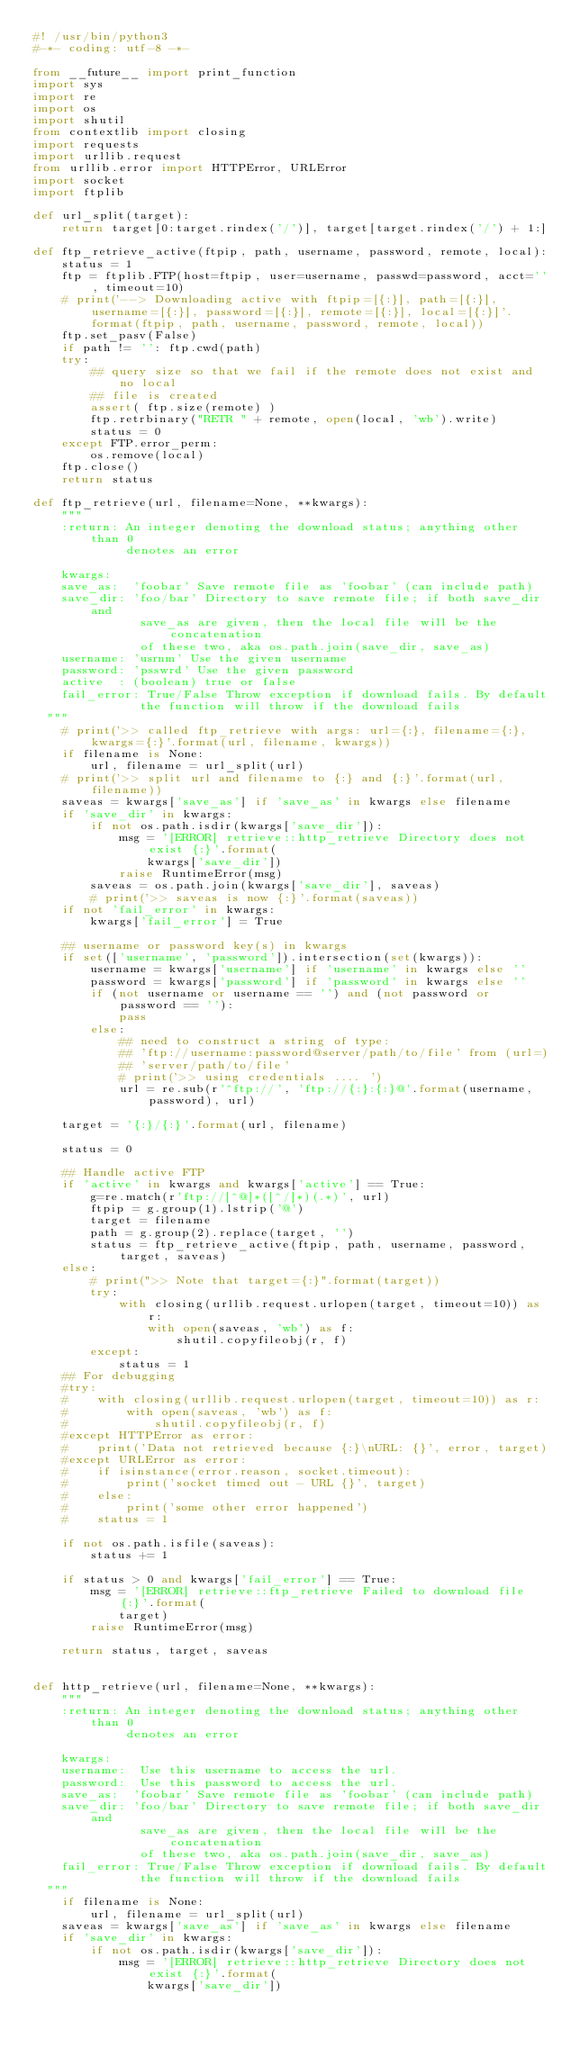<code> <loc_0><loc_0><loc_500><loc_500><_Python_>#! /usr/bin/python3
#-*- coding: utf-8 -*-

from __future__ import print_function
import sys
import re
import os
import shutil
from contextlib import closing
import requests
import urllib.request
from urllib.error import HTTPError, URLError
import socket
import ftplib

def url_split(target):
    return target[0:target.rindex('/')], target[target.rindex('/') + 1:]

def ftp_retrieve_active(ftpip, path, username, password, remote, local):
    status = 1
    ftp = ftplib.FTP(host=ftpip, user=username, passwd=password, acct='', timeout=10)
    # print('--> Downloading active with ftpip=[{:}], path=[{:}], username=[{:}], password=[{:}], remote=[{:}], local=[{:}]'.format(ftpip, path, username, password, remote, local))
    ftp.set_pasv(False)
    if path != '': ftp.cwd(path)
    try:
        ## query size so that we fail if the remote does not exist and no local
        ## file is created
        assert( ftp.size(remote) )
        ftp.retrbinary("RETR " + remote, open(local, 'wb').write)
        status = 0
    except FTP.error_perm:
        os.remove(local)
    ftp.close()
    return status

def ftp_retrieve(url, filename=None, **kwargs):
    """
    :return: An integer denoting the download status; anything other than 0 
             denotes an error

    kwargs:
    save_as:  'foobar' Save remote file as 'foobar' (can include path)
    save_dir: 'foo/bar' Directory to save remote file; if both save_dir and 
               save_as are given, then the local file will be the concatenation
               of these two, aka os.path.join(save_dir, save_as)
    username: 'usrnm' Use the given username
    password: 'psswrd' Use the given password
    active  : (boolean) true or false
    fail_error: True/False Throw exception if download fails. By default
               the function will throw if the download fails
  """
    # print('>> called ftp_retrieve with args: url={:}, filename={:}, kwargs={:}'.format(url, filename, kwargs))
    if filename is None:
        url, filename = url_split(url)
    # print('>> split url and filename to {:} and {:}'.format(url, filename))
    saveas = kwargs['save_as'] if 'save_as' in kwargs else filename
    if 'save_dir' in kwargs:
        if not os.path.isdir(kwargs['save_dir']):
            msg = '[ERROR] retrieve::http_retrieve Directory does not exist {:}'.format(
                kwargs['save_dir'])
            raise RuntimeError(msg)
        saveas = os.path.join(kwargs['save_dir'], saveas)
        # print('>> saveas is now {:}'.format(saveas))
    if not 'fail_error' in kwargs:
        kwargs['fail_error'] = True

    ## username or password key(s) in kwargs
    if set(['username', 'password']).intersection(set(kwargs)):
        username = kwargs['username'] if 'username' in kwargs else ''
        password = kwargs['password'] if 'password' in kwargs else ''
        if (not username or username == '') and (not password or password == ''):
            pass
        else:
            ## need to construct a string of type:
            ## 'ftp://username:password@server/path/to/file' from (url=)
            ## 'server/path/to/file'
            # print('>> using credentials .... ')
            url = re.sub(r'^ftp://', 'ftp://{:}:{:}@'.format(username, password), url)

    target = '{:}/{:}'.format(url, filename)

    status = 0
    
    ## Handle active FTP
    if 'active' in kwargs and kwargs['active'] == True:
        g=re.match(r'ftp://[^@]*([^/]*)(.*)', url)
        ftpip = g.group(1).lstrip('@')
        target = filename
        path = g.group(2).replace(target, '')
        status = ftp_retrieve_active(ftpip, path, username, password, target, saveas)
    else:
        # print(">> Note that target={:}".format(target))
        try:
            with closing(urllib.request.urlopen(target, timeout=10)) as r:
                with open(saveas, 'wb') as f:
                    shutil.copyfileobj(r, f)
        except:
            status = 1
    ## For debugging
    #try:
    #    with closing(urllib.request.urlopen(target, timeout=10)) as r:
    #        with open(saveas, 'wb') as f:
    #            shutil.copyfileobj(r, f)
    #except HTTPError as error:
    #    print('Data not retrieved because {:}\nURL: {}', error, target)
    #except URLError as error:
    #    if isinstance(error.reason, socket.timeout):
    #        print('socket timed out - URL {}', target)
    #    else:
    #        print('some other error happened')
    #    status = 1
    
    if not os.path.isfile(saveas):
        status += 1

    if status > 0 and kwargs['fail_error'] == True:
        msg = '[ERROR] retrieve::ftp_retrieve Failed to download file {:}'.format(
            target)
        raise RuntimeError(msg)

    return status, target, saveas


def http_retrieve(url, filename=None, **kwargs):
    """
    :return: An integer denoting the download status; anything other than 0 
             denotes an error

    kwargs:
    username:  Use this username to access the url.
    password:  Use this password to access the url.
    save_as:  'foobar' Save remote file as 'foobar' (can include path)
    save_dir: 'foo/bar' Directory to save remote file; if both save_dir and 
               save_as are given, then the local file will be the concatenation
               of these two, aka os.path.join(save_dir, save_as)
    fail_error: True/False Throw exception if download fails. By default
               the function will throw if the download fails
  """
    if filename is None:
        url, filename = url_split(url)
    saveas = kwargs['save_as'] if 'save_as' in kwargs else filename
    if 'save_dir' in kwargs:
        if not os.path.isdir(kwargs['save_dir']):
            msg = '[ERROR] retrieve::http_retrieve Directory does not exist {:}'.format(
                kwargs['save_dir'])</code> 